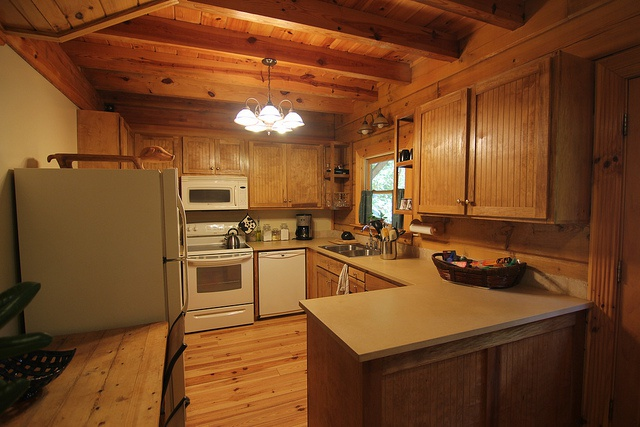Describe the objects in this image and their specific colors. I can see refrigerator in maroon, olive, and black tones, dining table in maroon, brown, and black tones, oven in maroon and tan tones, microwave in maroon, tan, and black tones, and chair in maroon, black, and brown tones in this image. 